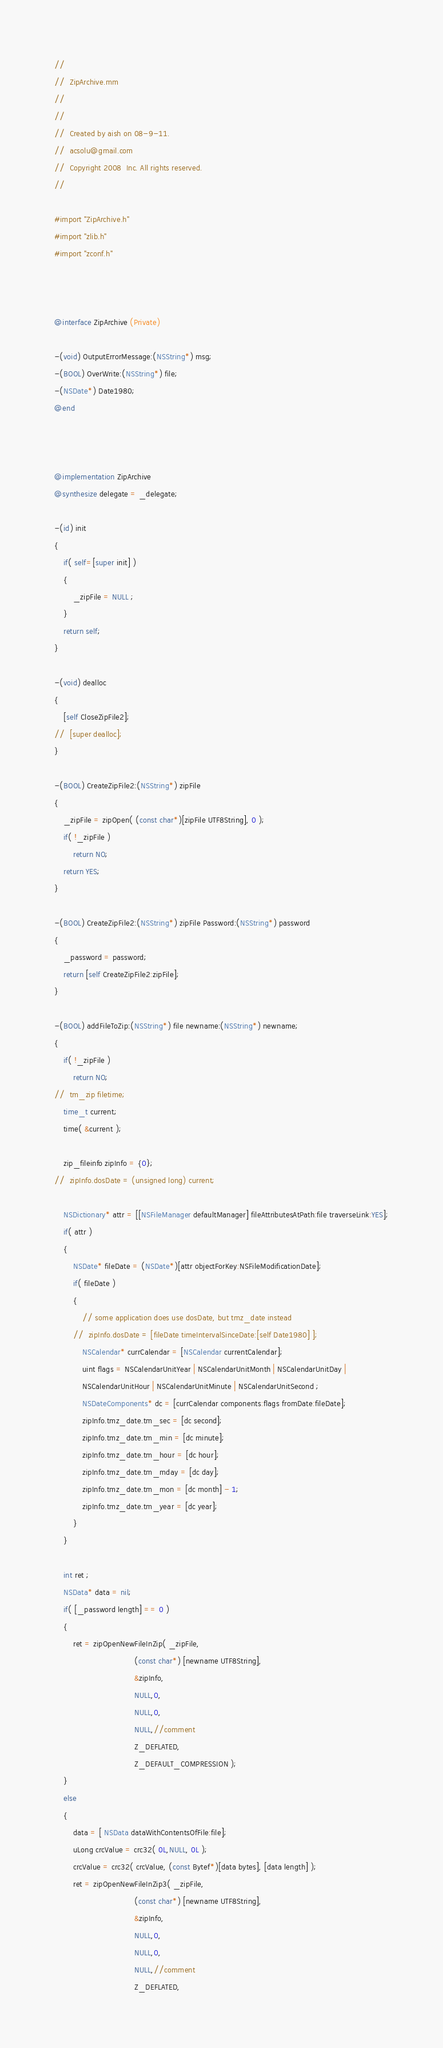Convert code to text. <code><loc_0><loc_0><loc_500><loc_500><_ObjectiveC_>//
//  ZipArchive.mm
//  
//
//  Created by aish on 08-9-11.
//  acsolu@gmail.com
//  Copyright 2008  Inc. All rights reserved.
//

#import "ZipArchive.h"
#import "zlib.h"
#import "zconf.h"



@interface ZipArchive (Private)

-(void) OutputErrorMessage:(NSString*) msg;
-(BOOL) OverWrite:(NSString*) file;
-(NSDate*) Date1980;
@end



@implementation ZipArchive
@synthesize delegate = _delegate;

-(id) init
{
	if( self=[super init] )
	{
		_zipFile = NULL ;
	}
	return self;
}

-(void) dealloc
{
	[self CloseZipFile2];
//	[super dealloc];
}

-(BOOL) CreateZipFile2:(NSString*) zipFile
{
	_zipFile = zipOpen( (const char*)[zipFile UTF8String], 0 );
	if( !_zipFile ) 
		return NO;
	return YES;
}

-(BOOL) CreateZipFile2:(NSString*) zipFile Password:(NSString*) password
{
	_password = password;
	return [self CreateZipFile2:zipFile];
}

-(BOOL) addFileToZip:(NSString*) file newname:(NSString*) newname;
{
	if( !_zipFile )
		return NO;
//	tm_zip filetime;
	time_t current;
	time( &current );
	
	zip_fileinfo zipInfo = {0};
//	zipInfo.dosDate = (unsigned long) current;
	
	NSDictionary* attr = [[NSFileManager defaultManager] fileAttributesAtPath:file traverseLink:YES];
	if( attr )
	{
		NSDate* fileDate = (NSDate*)[attr objectForKey:NSFileModificationDate];
		if( fileDate )
		{
			// some application does use dosDate, but tmz_date instead
		//	zipInfo.dosDate = [fileDate timeIntervalSinceDate:[self Date1980] ];
			NSCalendar* currCalendar = [NSCalendar currentCalendar];
            uint flags = NSCalendarUnitYear | NSCalendarUnitMonth | NSCalendarUnitDay |
            NSCalendarUnitHour | NSCalendarUnitMinute | NSCalendarUnitSecond ;
			NSDateComponents* dc = [currCalendar components:flags fromDate:fileDate];
			zipInfo.tmz_date.tm_sec = [dc second];
			zipInfo.tmz_date.tm_min = [dc minute];
			zipInfo.tmz_date.tm_hour = [dc hour];
			zipInfo.tmz_date.tm_mday = [dc day];
			zipInfo.tmz_date.tm_mon = [dc month] - 1;
			zipInfo.tmz_date.tm_year = [dc year];
		}
	}
	
	int ret ;
	NSData* data = nil;
	if( [_password length] == 0 )
	{
		ret = zipOpenNewFileInZip( _zipFile,
								  (const char*) [newname UTF8String],
								  &zipInfo,
								  NULL,0,
								  NULL,0,
								  NULL,//comment
								  Z_DEFLATED,
								  Z_DEFAULT_COMPRESSION );
	}
	else
	{
		data = [ NSData dataWithContentsOfFile:file];
		uLong crcValue = crc32( 0L,NULL, 0L );
		crcValue = crc32( crcValue, (const Bytef*)[data bytes], [data length] );
		ret = zipOpenNewFileInZip3( _zipFile,
								  (const char*) [newname UTF8String],
								  &zipInfo,
								  NULL,0,
								  NULL,0,
								  NULL,//comment
								  Z_DEFLATED,</code> 